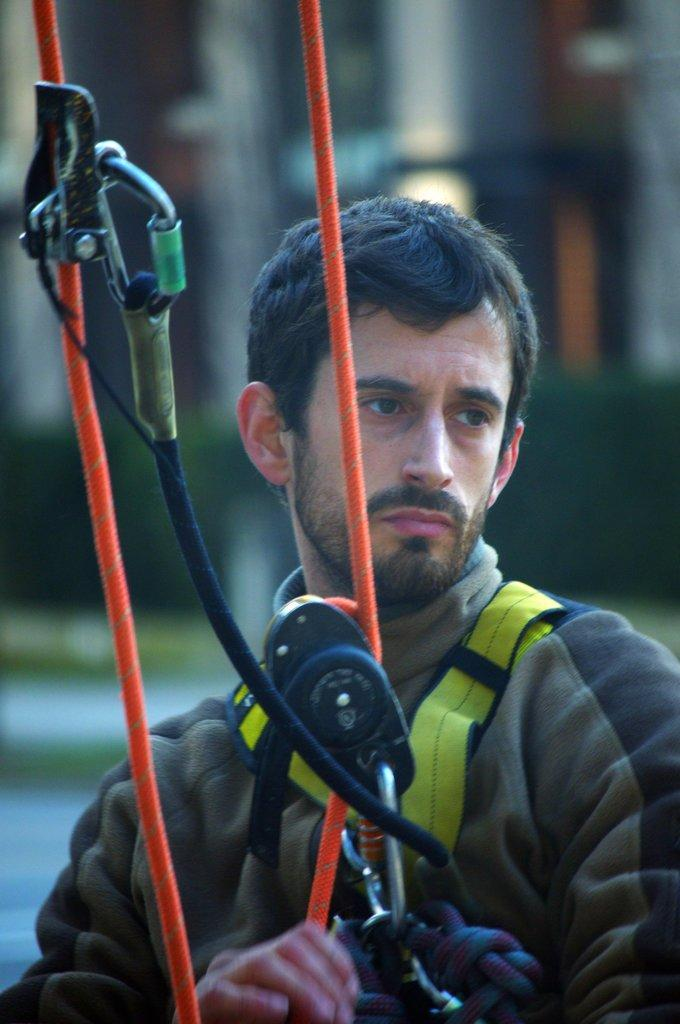What can be seen in the image? There is a person in the image. What is the person doing in the image? The person is holding an object. Can you describe the ropes in the image? The ropes in the image are red colored. What color are the objects in the image? The objects in the image are black colored. How would you describe the background of the image? The background of the image is blurred. Where is the loaf of bread placed in the image? There is no loaf of bread present in the image. Is the person in the image a spy? There is no information in the image to suggest that the person is a spy. 